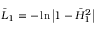<formula> <loc_0><loc_0><loc_500><loc_500>\bar { L } _ { 1 } = - \ln \left | 1 - \bar { H } _ { 1 } ^ { 2 } \right |</formula> 